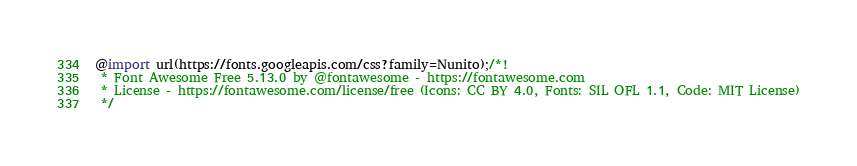<code> <loc_0><loc_0><loc_500><loc_500><_CSS_>@import url(https://fonts.googleapis.com/css?family=Nunito);/*!
 * Font Awesome Free 5.13.0 by @fontawesome - https://fontawesome.com
 * License - https://fontawesome.com/license/free (Icons: CC BY 4.0, Fonts: SIL OFL 1.1, Code: MIT License)
 */</code> 